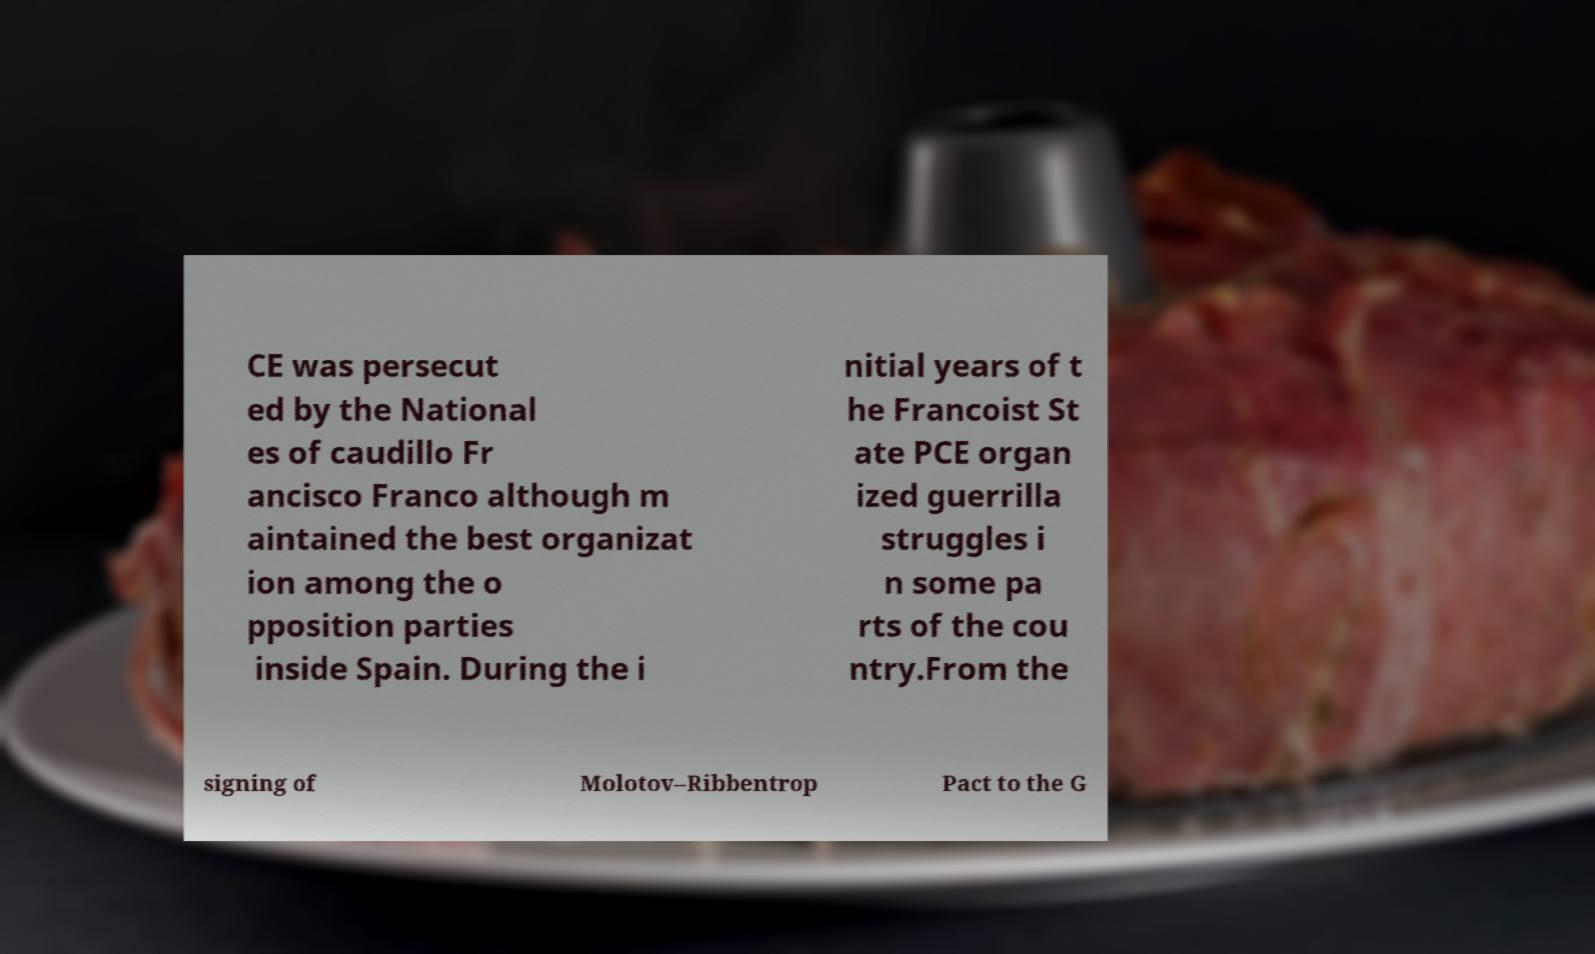What messages or text are displayed in this image? I need them in a readable, typed format. CE was persecut ed by the National es of caudillo Fr ancisco Franco although m aintained the best organizat ion among the o pposition parties inside Spain. During the i nitial years of t he Francoist St ate PCE organ ized guerrilla struggles i n some pa rts of the cou ntry.From the signing of Molotov–Ribbentrop Pact to the G 